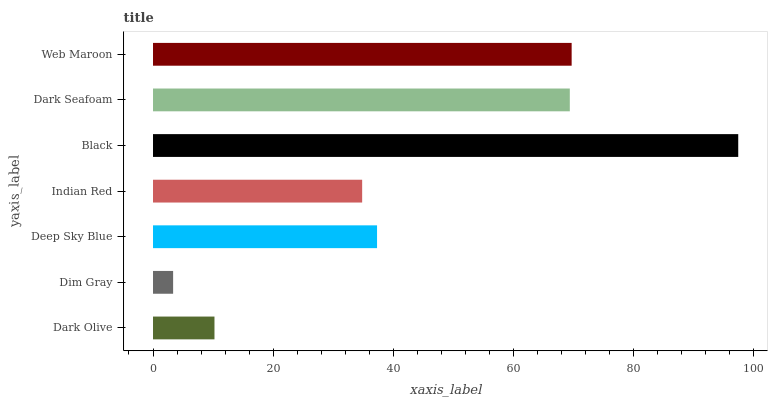Is Dim Gray the minimum?
Answer yes or no. Yes. Is Black the maximum?
Answer yes or no. Yes. Is Deep Sky Blue the minimum?
Answer yes or no. No. Is Deep Sky Blue the maximum?
Answer yes or no. No. Is Deep Sky Blue greater than Dim Gray?
Answer yes or no. Yes. Is Dim Gray less than Deep Sky Blue?
Answer yes or no. Yes. Is Dim Gray greater than Deep Sky Blue?
Answer yes or no. No. Is Deep Sky Blue less than Dim Gray?
Answer yes or no. No. Is Deep Sky Blue the high median?
Answer yes or no. Yes. Is Deep Sky Blue the low median?
Answer yes or no. Yes. Is Indian Red the high median?
Answer yes or no. No. Is Indian Red the low median?
Answer yes or no. No. 